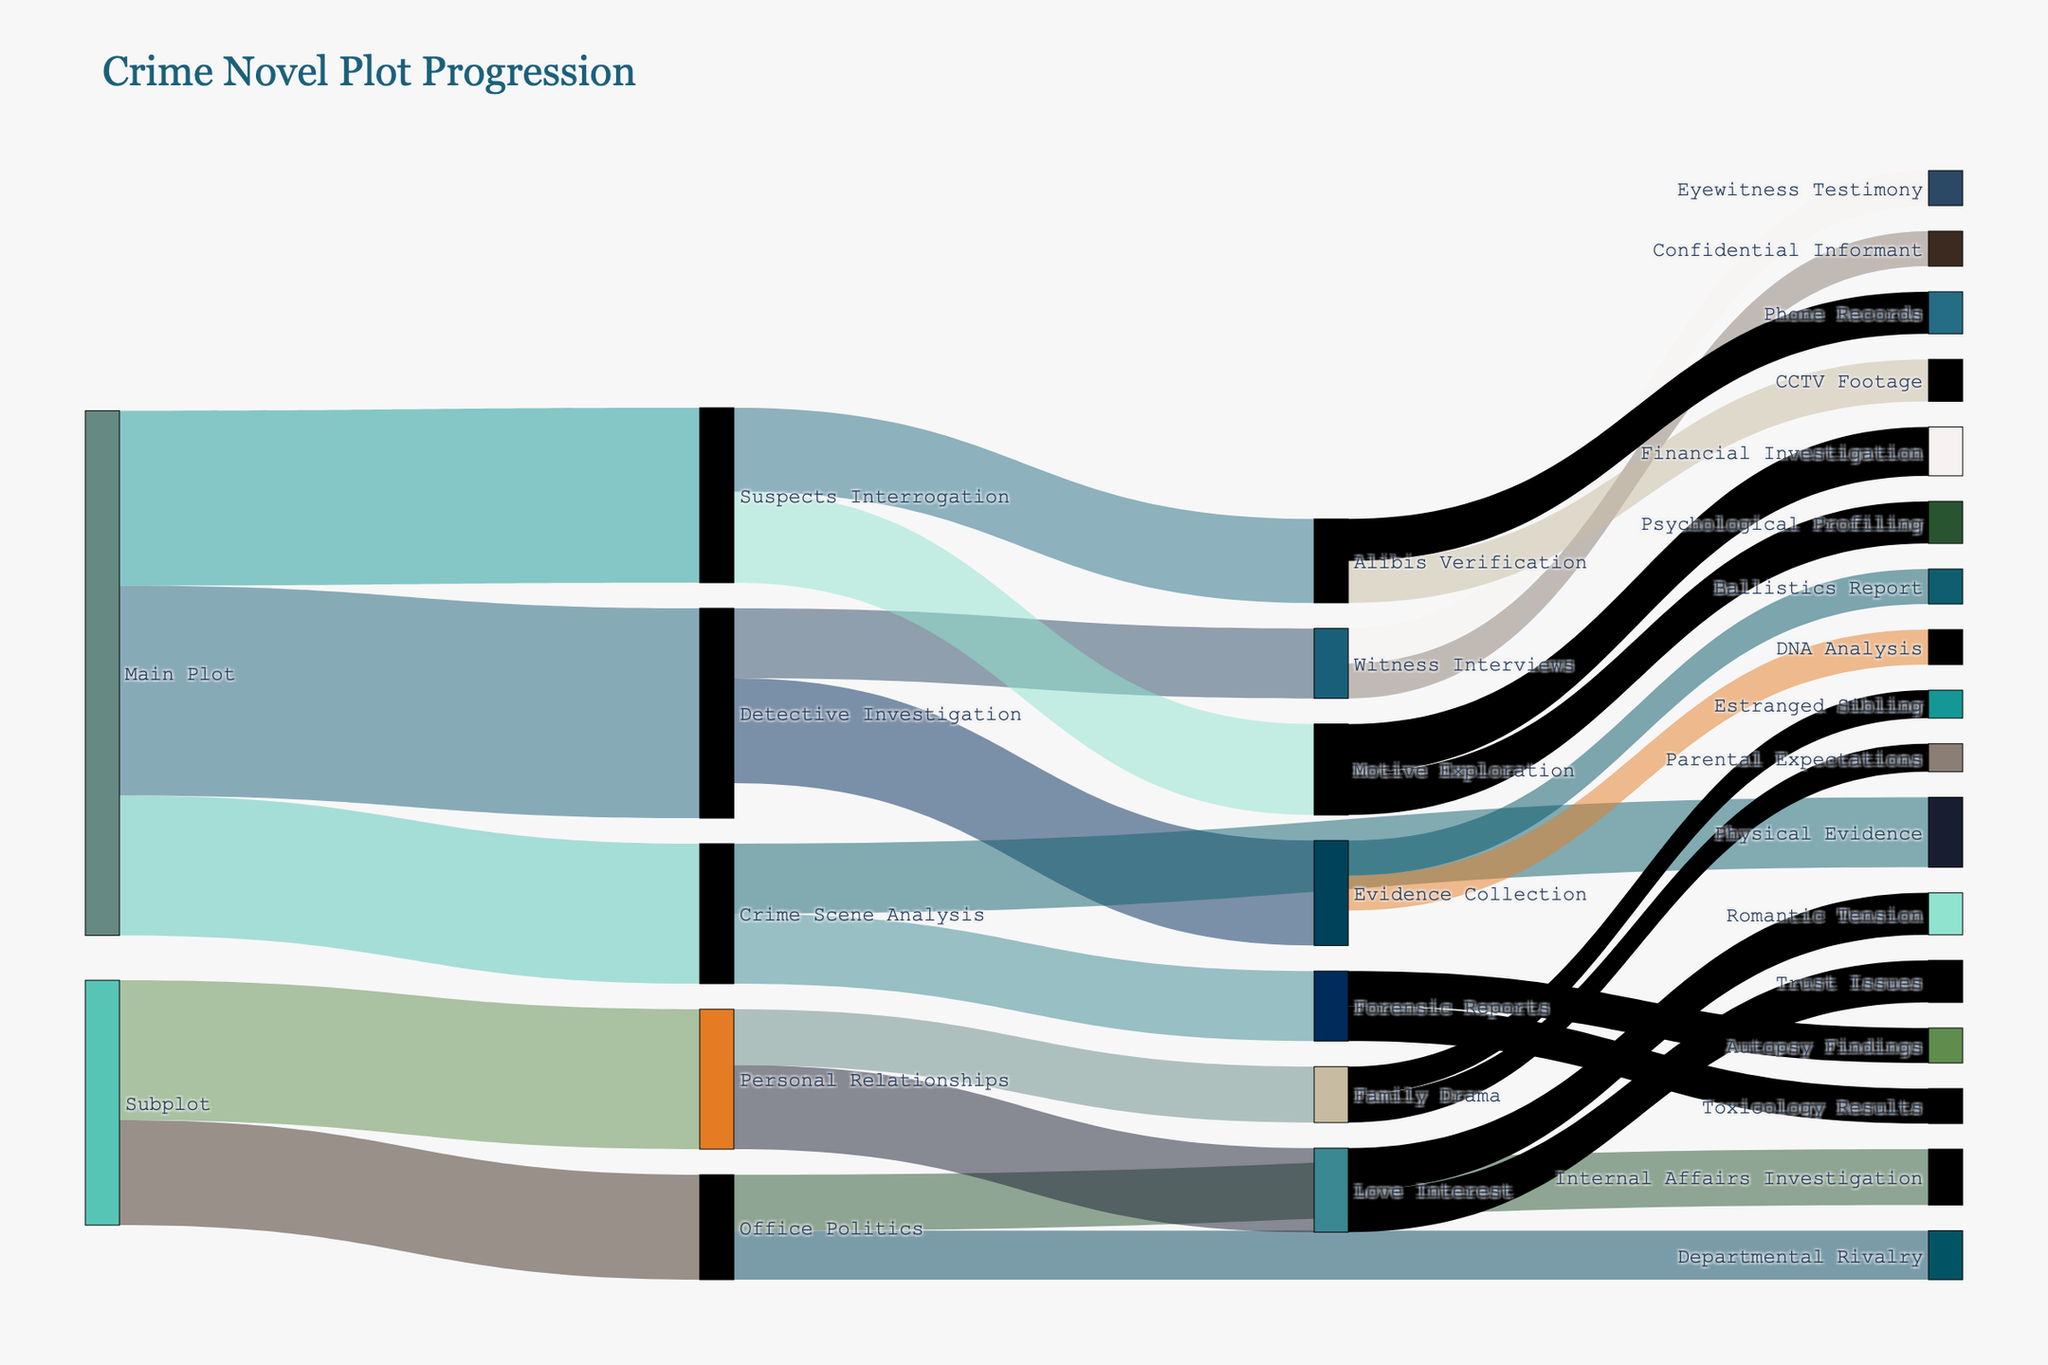What's the title of the plot? The title is typically placed at the top of the figure. It reads "Crime Novel Plot Progression".
Answer: Crime Novel Plot Progression What's the total value of interactions originating from the Main Plot? To find the total value, sum up all values originating from the Main Plot: 30 (Detective Investigation) + 25 (Suspects Interrogation) + 20 (Crime Scene Analysis).
Answer: 75 Which subplot has the highest value? Compare the values of subplots: Office Politics (15) and Personal Relationships (20). Personal Relationships has a higher value.
Answer: Personal Relationships How many distinct nodes are present in the figure? Count all different nodes by considering both source and target columns. There are 21 unique nodes.
Answer: 21 What's the sum of values flowing into the category "Forensic Reports"? Add the values targeting Forensic Reports: 5 (Toxicology Results) + 5 (Autopsy Findings).
Answer: 10 Which interaction category from the Detective Investigation has a higher value? Compare the values of Evidence Collection (15) and Witness Interviews (10). Evidence Collection is higher.
Answer: Evidence Collection What's the difference in values between Office Politics and Departmental Rivalry? Subtract the value of Departmental Rivalry (7) from Office Politics (8).
Answer: 1 Which target has the most connections from different sources? Count how many different sources target each node. Forensic Reports and Alibis Verification both have 2 different sources each.
Answer: Forensic Reports and Alibis Verification Which node contributes the least to its next interactions in the figure? Check all nodes and their flowing connections. The nodes Estranged Sibling and Parental Expectations each have a value of 4.
Answer: Estranged Sibling and Parental Expectations Is the value flowing into "Trust Issues" greater than the value flowing into "Toxicology Results"? Compare the values for Trust Issues (6) and Toxicology Results (5). Trust Issues is greater.
Answer: Yes 